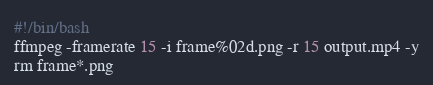<code> <loc_0><loc_0><loc_500><loc_500><_Bash_>#!/bin/bash
ffmpeg -framerate 15 -i frame%02d.png -r 15 output.mp4 -y
rm frame*.png

</code> 